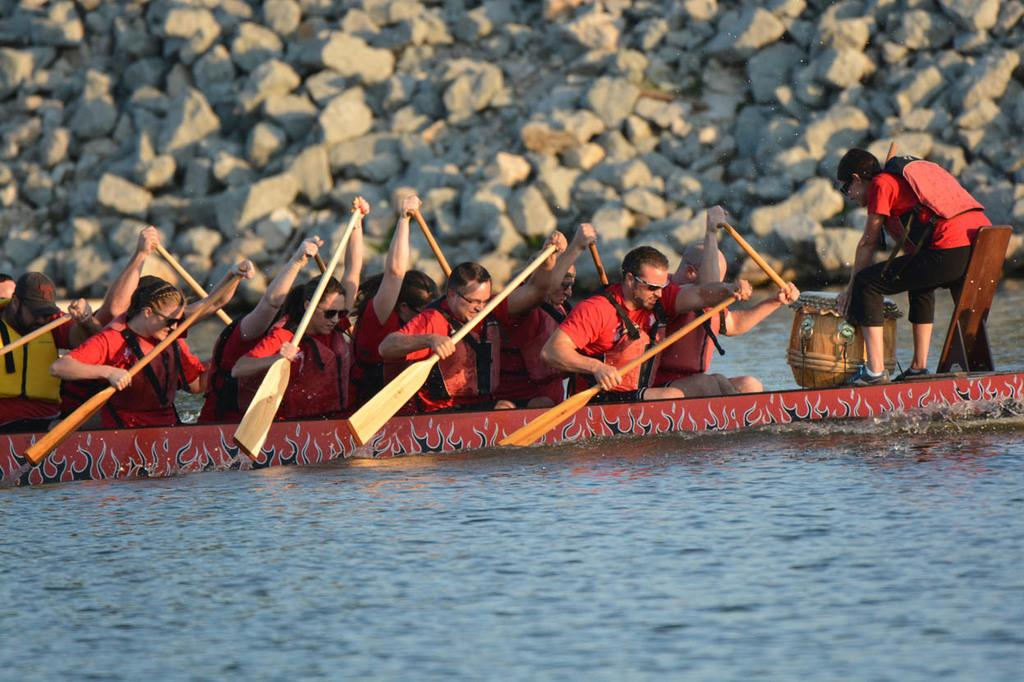What is the main subject of the image? The main subject of the image is a group of people. Where are the people located in the image? The people are on a boat in the image. What can be seen in the background of the image? There are stones visible in the background of the image. What is the primary setting of the image? The primary setting of the image is water, as the people are on a boat. What type of bird is perched on the trousers of the person in the image? There is no bird or trousers present in the image; it features a group of people on a boat with a background of stones. 